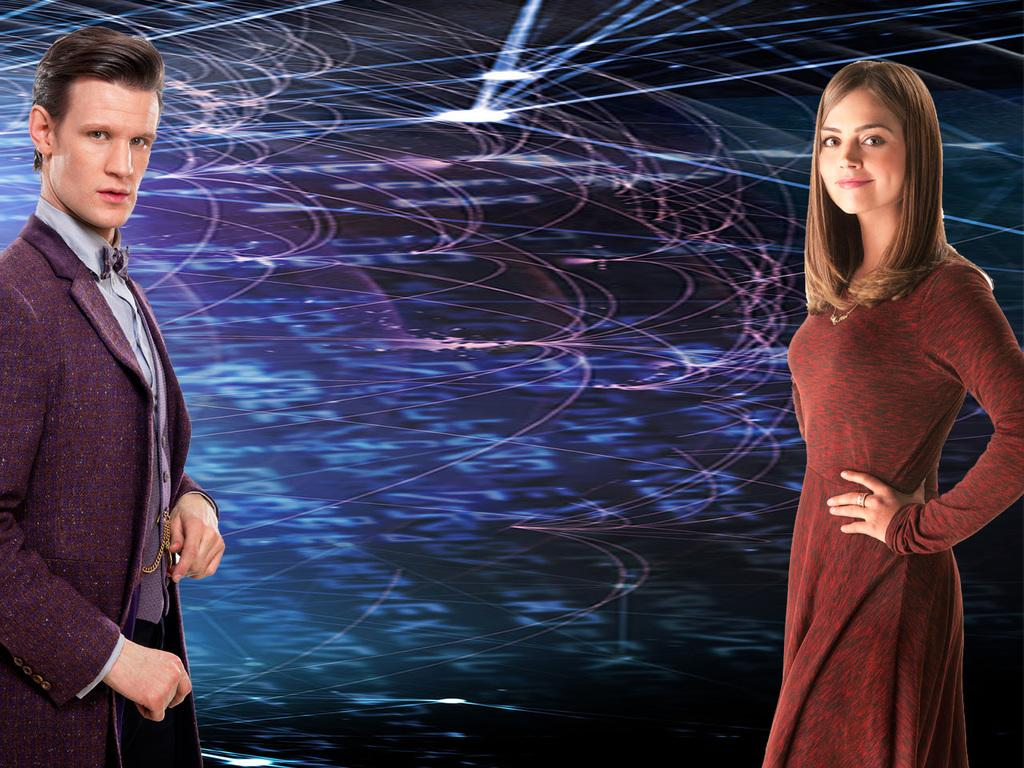How many people are present in the image? There is a lady and a man in the image. What is the main object in the image? There is a screen in the image. What can be seen on the screen? Light rays are visible on the screen. What type of beds can be seen in the image? There are no beds present in the image. Is there a doctor in the image? There is no doctor present in the image. What is the current state of the lady's digestion in the image? There is no information about the lady's digestion in the image. 